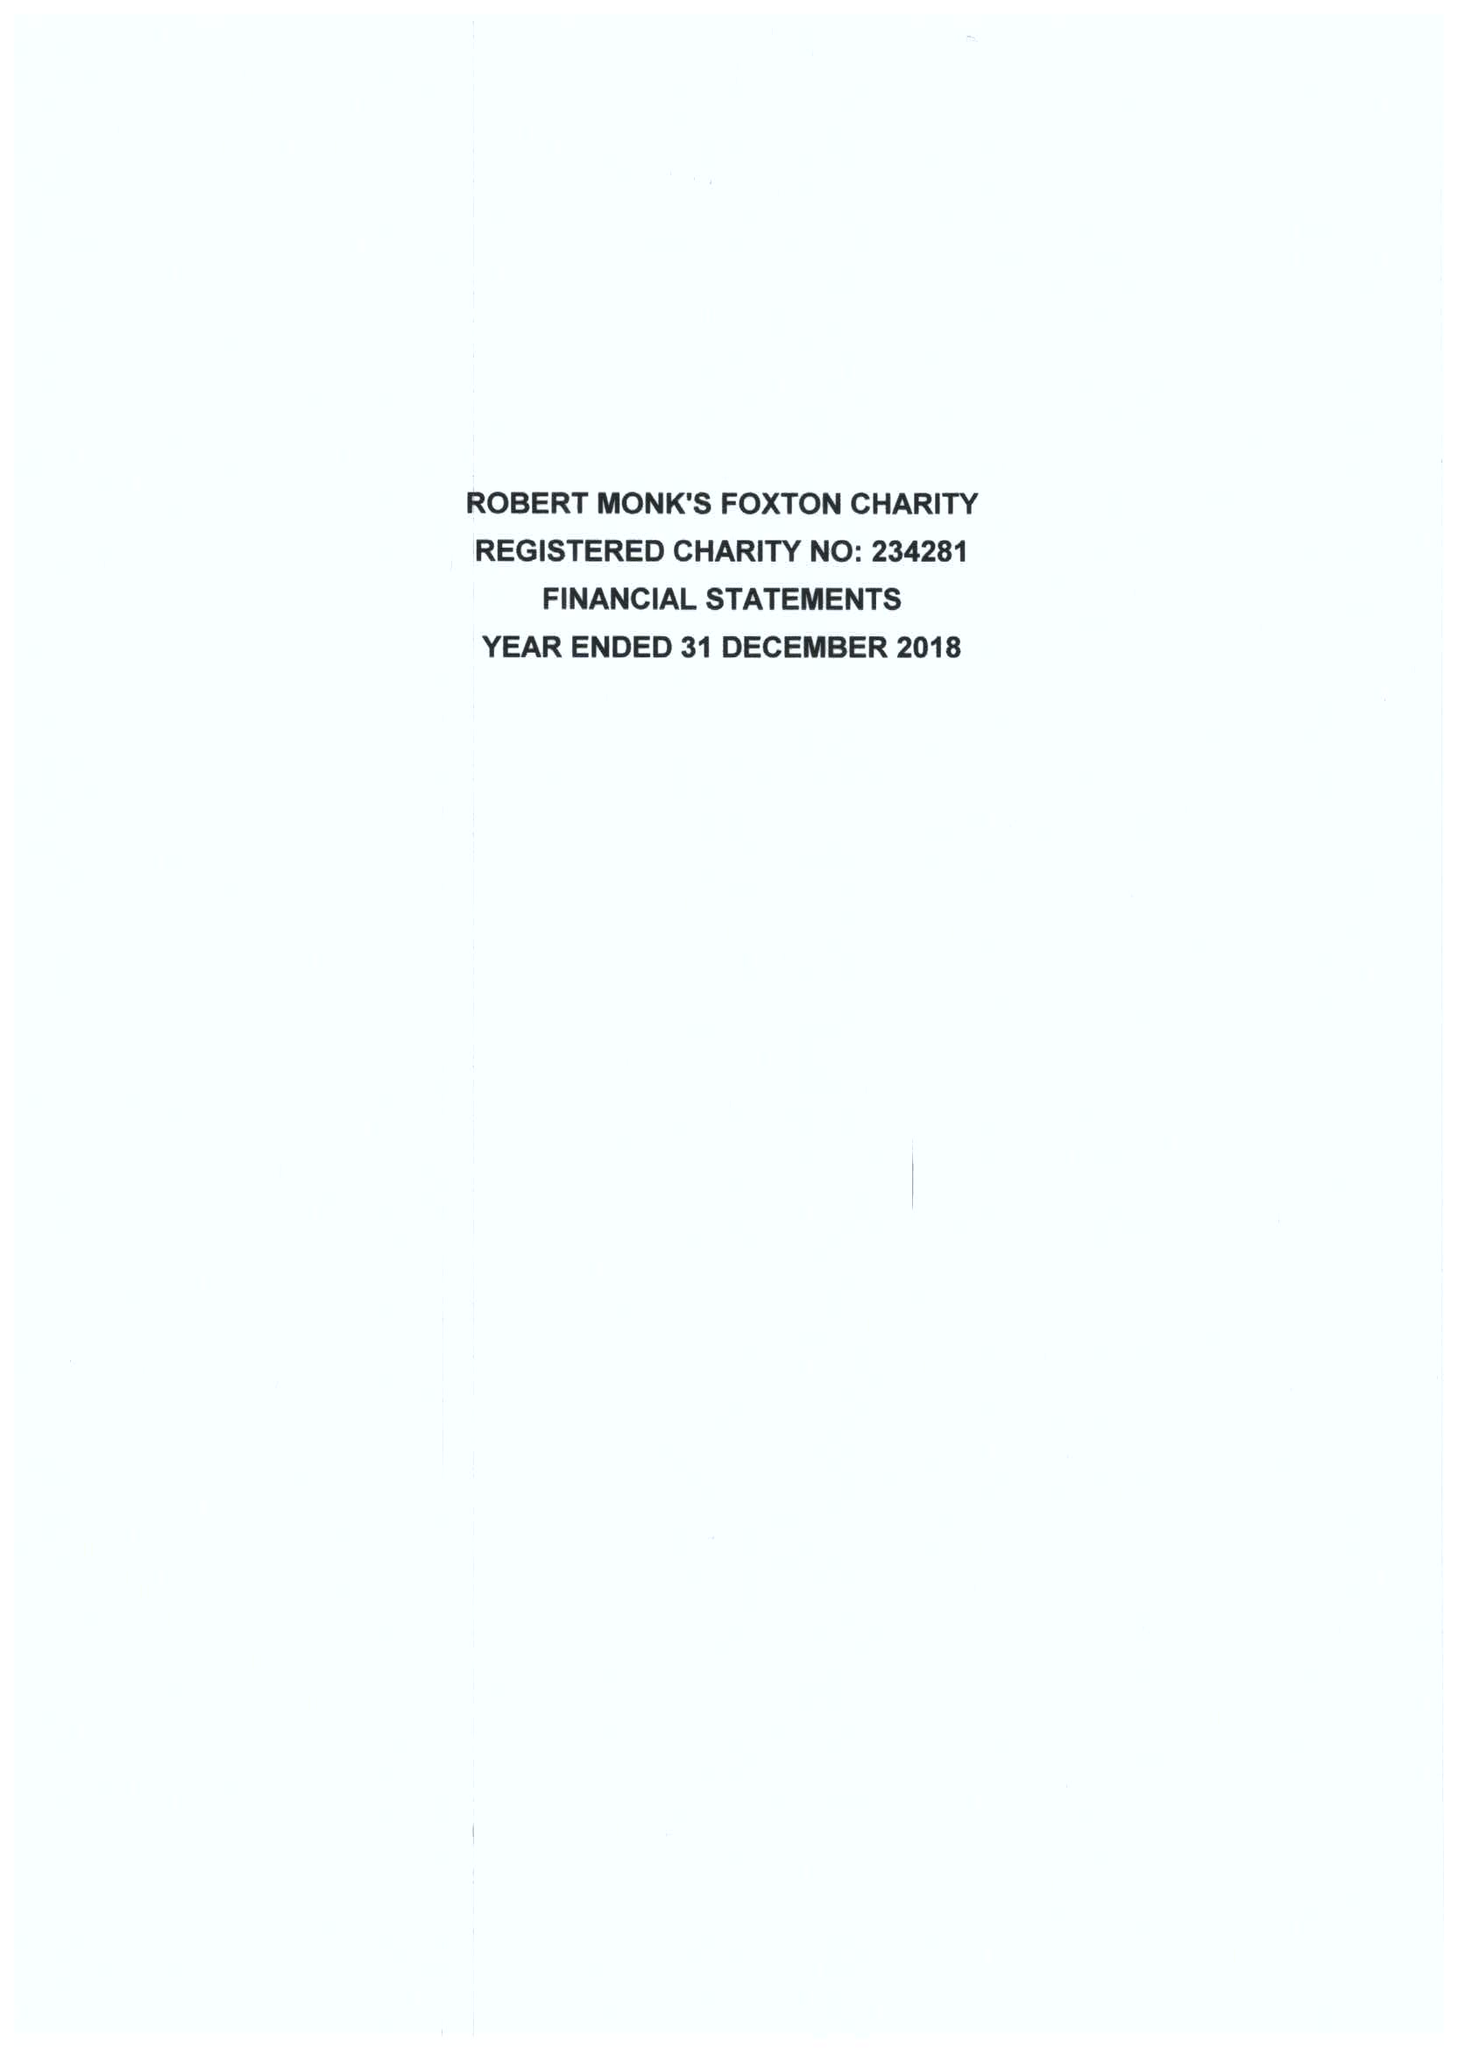What is the value for the income_annually_in_british_pounds?
Answer the question using a single word or phrase. 39086.00 